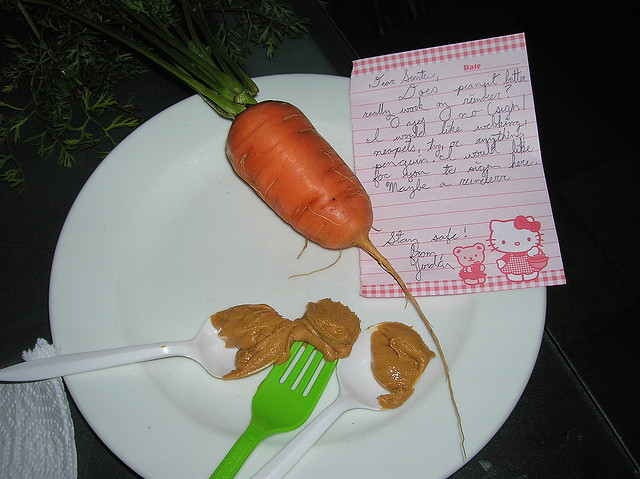Extract all visible text content from this image. Dear Does butter Prom Star a to here would penguin loc you ac l no like would oy really 